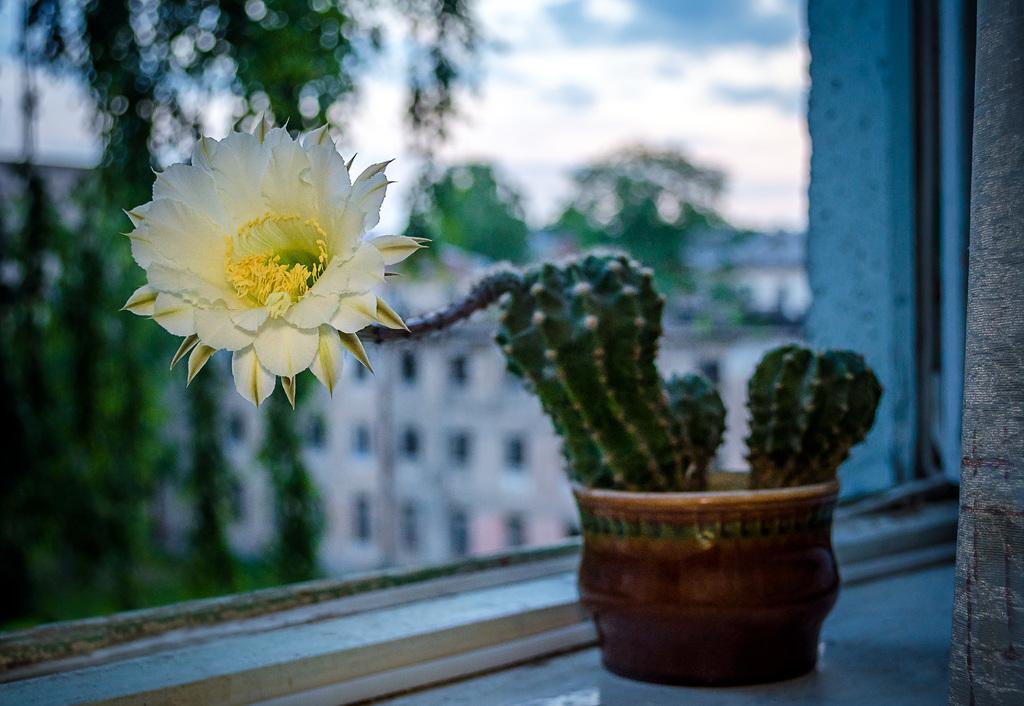Describe this image in one or two sentences. In this image there is a flower, behind the flower there is a cactus plant on the window shelf, behind the flower there is a glass window, from the window we can see trees and buildings and there are clouds in the sky. 